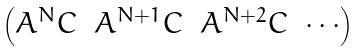<formula> <loc_0><loc_0><loc_500><loc_500>\begin{pmatrix} A ^ { N } C & A ^ { N + 1 } C & A ^ { N + 2 } C & \cdots \end{pmatrix}</formula> 